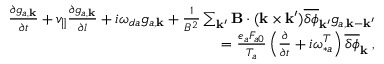<formula> <loc_0><loc_0><loc_500><loc_500>\begin{array} { r } { \frac { \partial g _ { a , { k } } } { \partial t } + v _ { \| } \frac { \partial g _ { a , { k } } } { \partial l } + i \omega _ { d a } g _ { a , { k } } + \frac { 1 } { B ^ { 2 } } \sum _ { { k } ^ { \prime } } { B } \cdot ( { k } \times { k } ^ { \prime } ) \overline { \delta \phi } _ { { k } ^ { \prime } } g _ { a , { k } - { k } ^ { \prime } } } \\ { = \frac { e _ { a } F _ { a 0 } } { T _ { a } } \left ( \frac { \partial } { \partial t } + i \omega _ { \ast a } ^ { T } \right ) \overline { \delta \phi } _ { k } \, , } \end{array}</formula> 